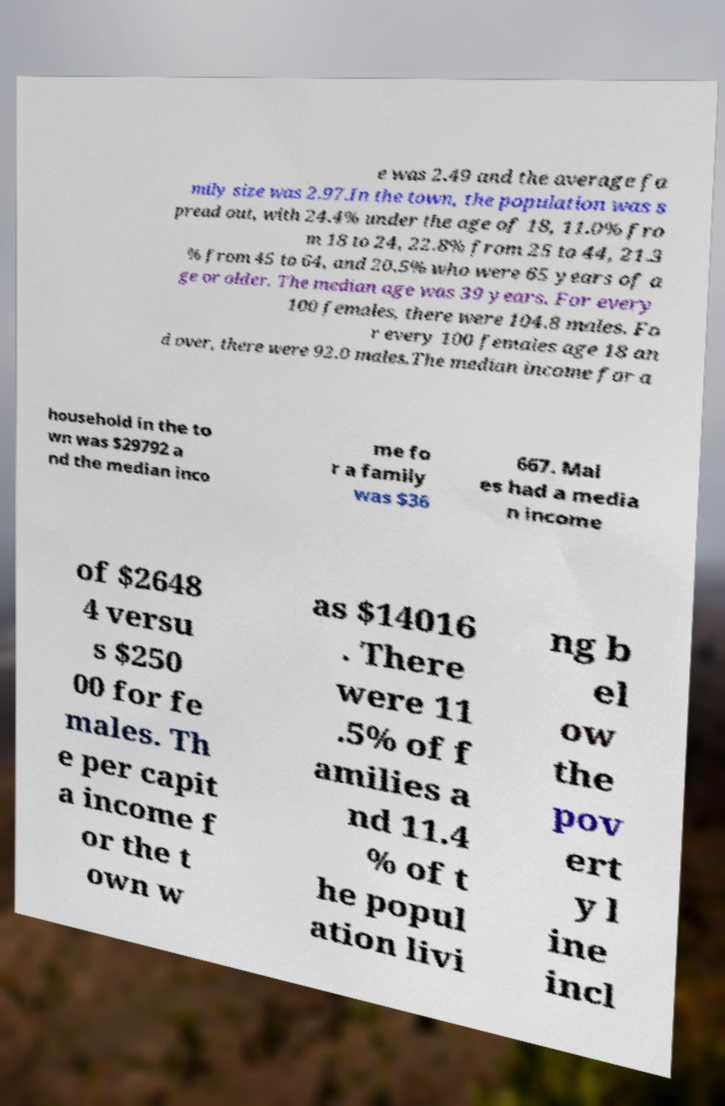For documentation purposes, I need the text within this image transcribed. Could you provide that? e was 2.49 and the average fa mily size was 2.97.In the town, the population was s pread out, with 24.4% under the age of 18, 11.0% fro m 18 to 24, 22.8% from 25 to 44, 21.3 % from 45 to 64, and 20.5% who were 65 years of a ge or older. The median age was 39 years. For every 100 females, there were 104.8 males. Fo r every 100 females age 18 an d over, there were 92.0 males.The median income for a household in the to wn was $29792 a nd the median inco me fo r a family was $36 667. Mal es had a media n income of $2648 4 versu s $250 00 for fe males. Th e per capit a income f or the t own w as $14016 . There were 11 .5% of f amilies a nd 11.4 % of t he popul ation livi ng b el ow the pov ert y l ine incl 